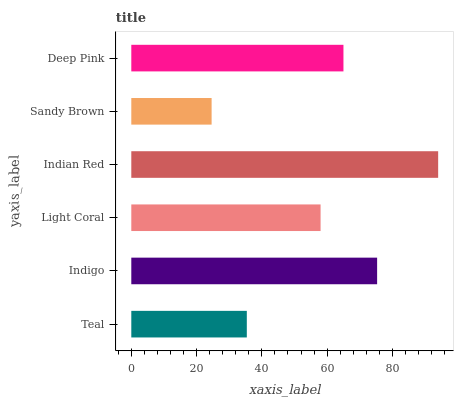Is Sandy Brown the minimum?
Answer yes or no. Yes. Is Indian Red the maximum?
Answer yes or no. Yes. Is Indigo the minimum?
Answer yes or no. No. Is Indigo the maximum?
Answer yes or no. No. Is Indigo greater than Teal?
Answer yes or no. Yes. Is Teal less than Indigo?
Answer yes or no. Yes. Is Teal greater than Indigo?
Answer yes or no. No. Is Indigo less than Teal?
Answer yes or no. No. Is Deep Pink the high median?
Answer yes or no. Yes. Is Light Coral the low median?
Answer yes or no. Yes. Is Light Coral the high median?
Answer yes or no. No. Is Indigo the low median?
Answer yes or no. No. 